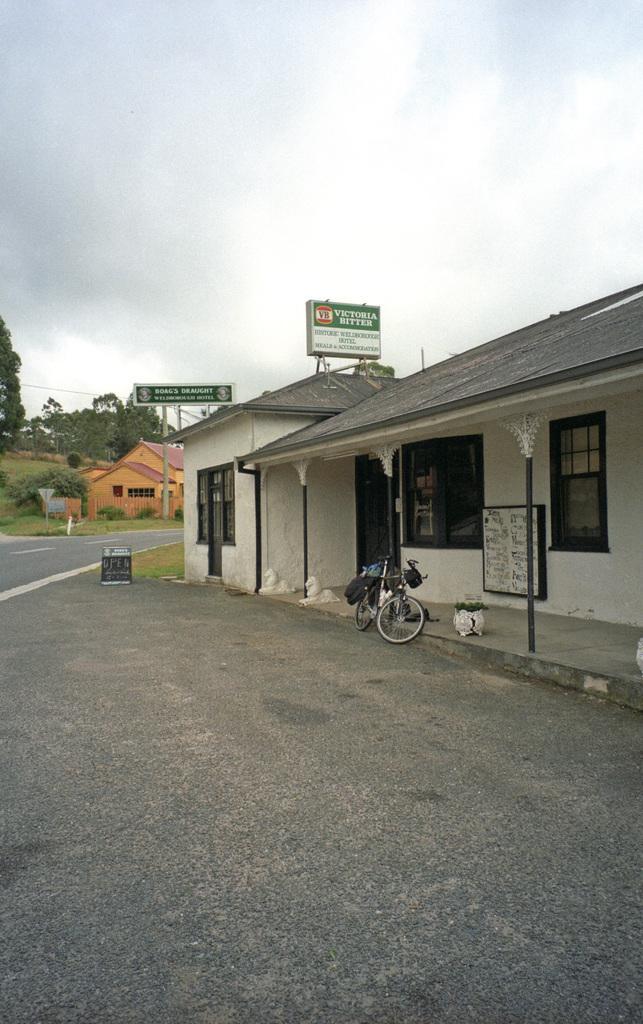Describe this image in one or two sentences. In this image we can see some houses with windows and roof, a plant in a pot, some boards with text on them, poles, a bicycle on the road, a group of trees, plants, wires and the sky which looks cloudy. 